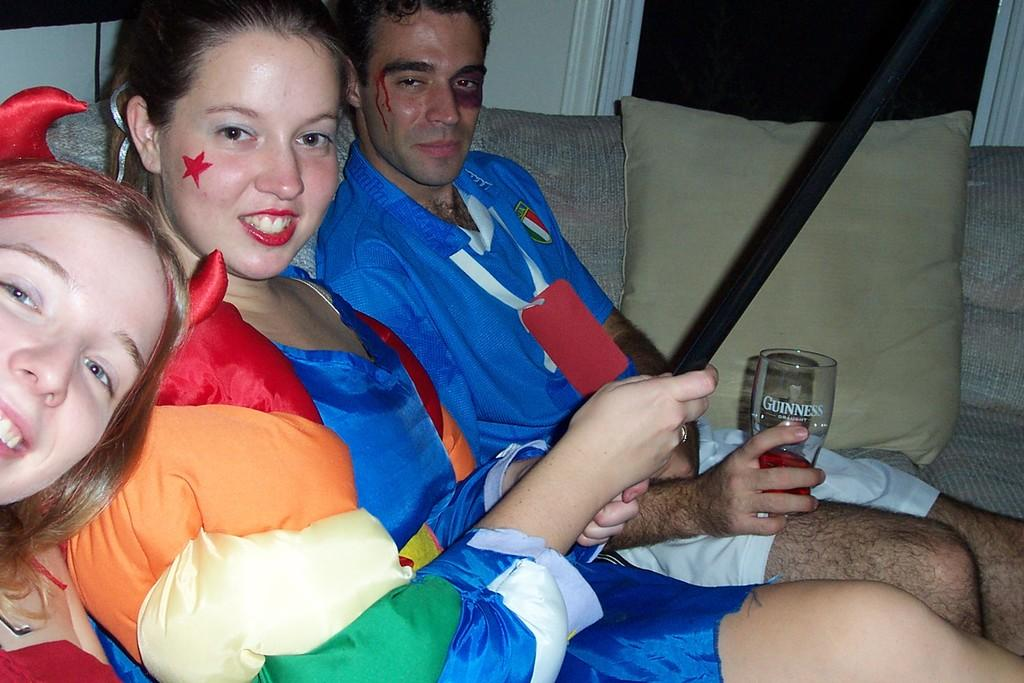<image>
Create a compact narrative representing the image presented. Two women and a man in costumes and the man is holding a Guinness glass 